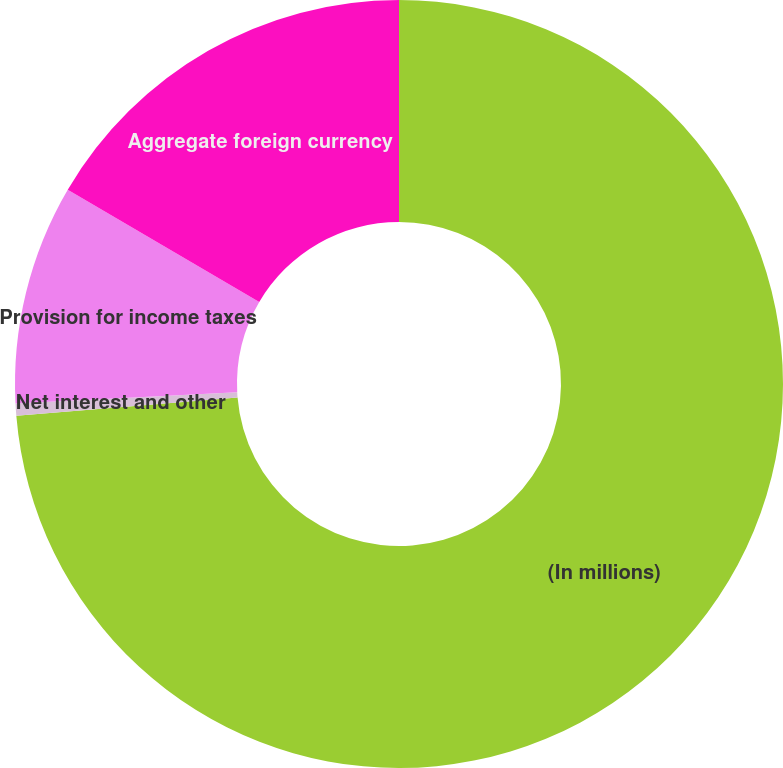Convert chart. <chart><loc_0><loc_0><loc_500><loc_500><pie_chart><fcel>(In millions)<fcel>Net interest and other<fcel>Provision for income taxes<fcel>Aggregate foreign currency<nl><fcel>73.68%<fcel>0.51%<fcel>9.25%<fcel>16.56%<nl></chart> 